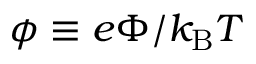<formula> <loc_0><loc_0><loc_500><loc_500>\phi \equiv e \Phi / k _ { B } T</formula> 